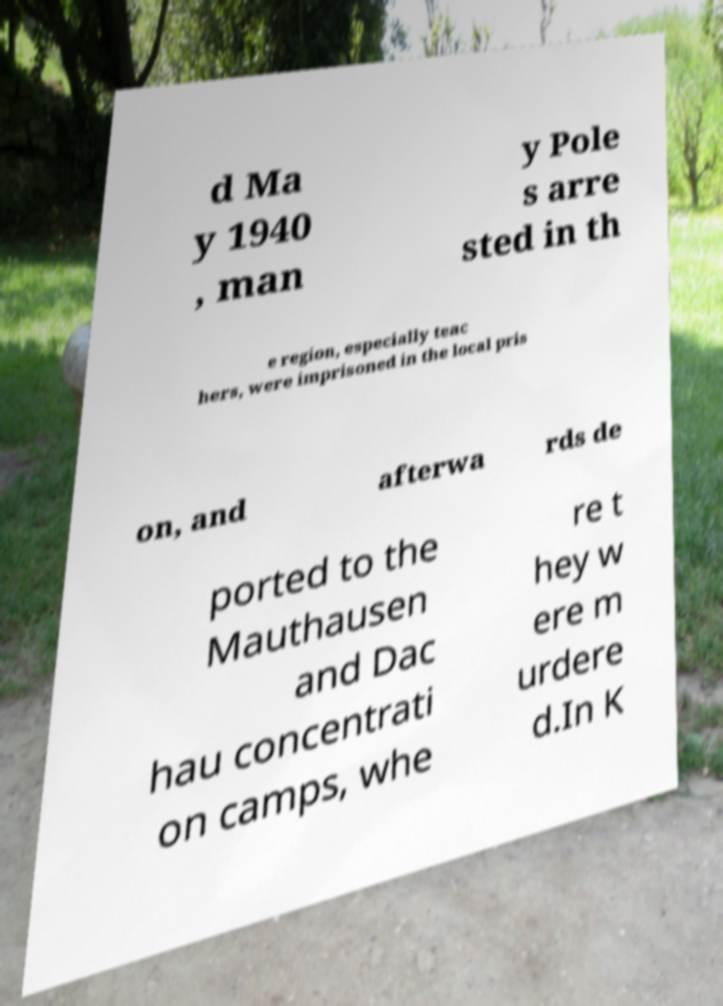For documentation purposes, I need the text within this image transcribed. Could you provide that? d Ma y 1940 , man y Pole s arre sted in th e region, especially teac hers, were imprisoned in the local pris on, and afterwa rds de ported to the Mauthausen and Dac hau concentrati on camps, whe re t hey w ere m urdere d.In K 